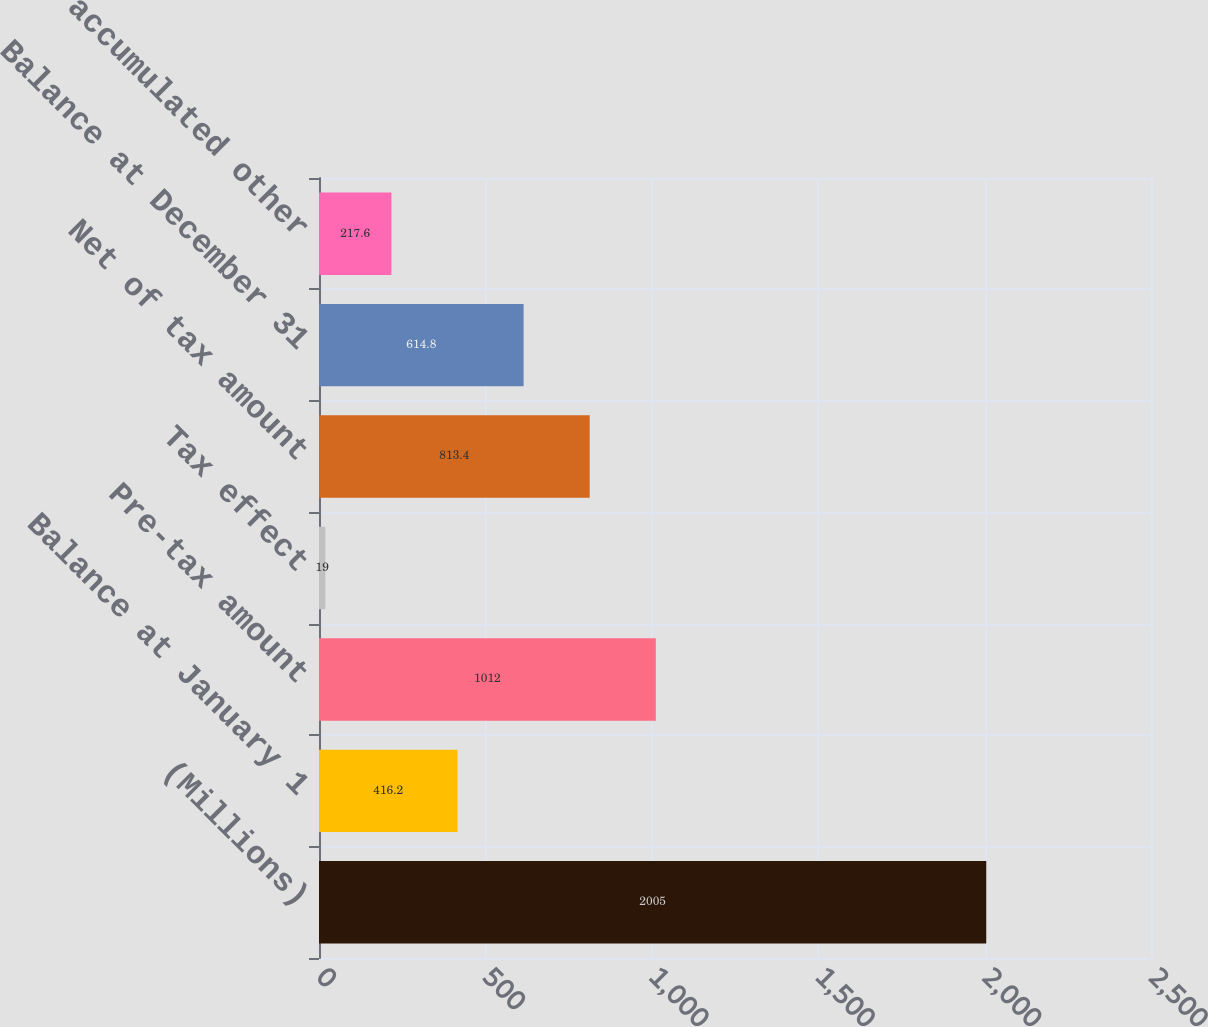Convert chart to OTSL. <chart><loc_0><loc_0><loc_500><loc_500><bar_chart><fcel>(Millions)<fcel>Balance at January 1<fcel>Pre-tax amount<fcel>Tax effect<fcel>Net of tax amount<fcel>Balance at December 31<fcel>Total accumulated other<nl><fcel>2005<fcel>416.2<fcel>1012<fcel>19<fcel>813.4<fcel>614.8<fcel>217.6<nl></chart> 